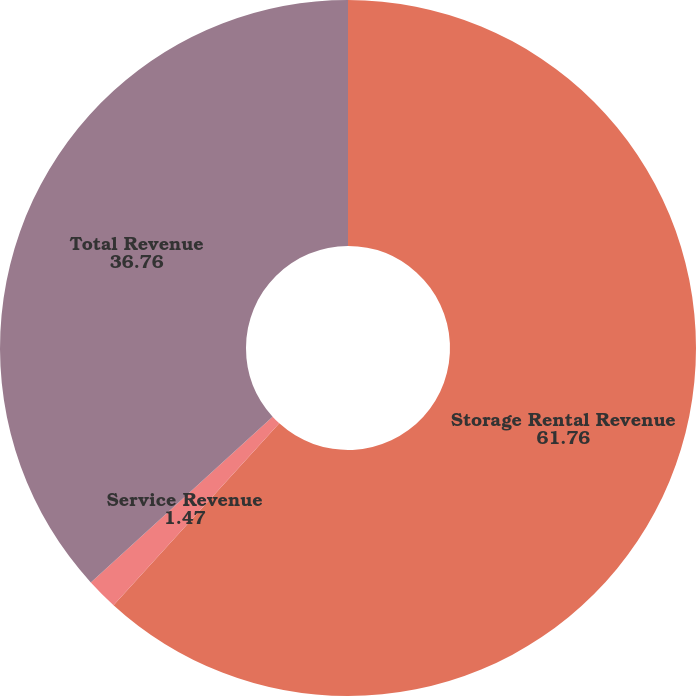Convert chart to OTSL. <chart><loc_0><loc_0><loc_500><loc_500><pie_chart><fcel>Storage Rental Revenue<fcel>Service Revenue<fcel>Total Revenue<nl><fcel>61.76%<fcel>1.47%<fcel>36.76%<nl></chart> 